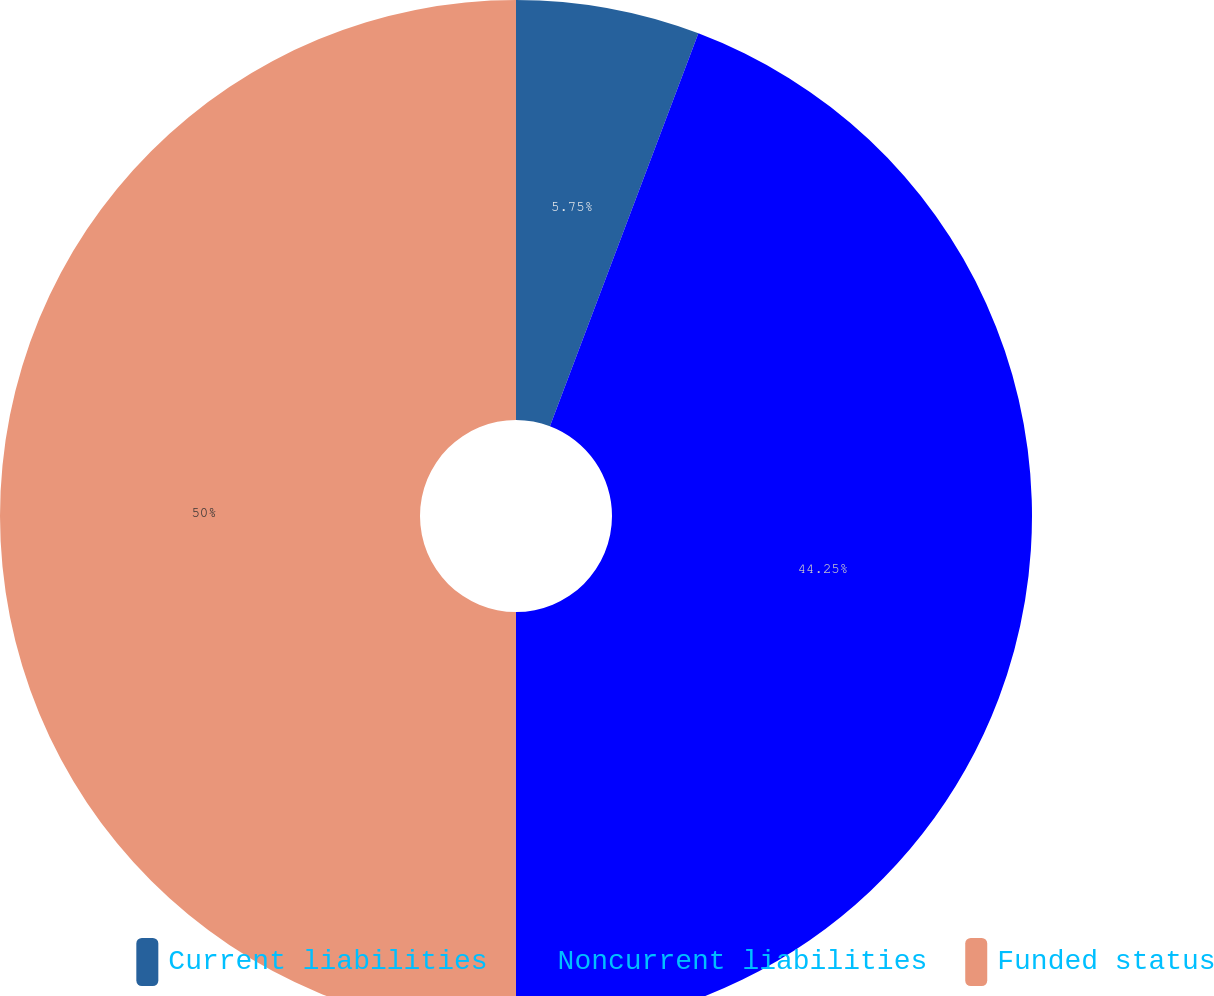Convert chart to OTSL. <chart><loc_0><loc_0><loc_500><loc_500><pie_chart><fcel>Current liabilities<fcel>Noncurrent liabilities<fcel>Funded status<nl><fcel>5.75%<fcel>44.25%<fcel>50.0%<nl></chart> 